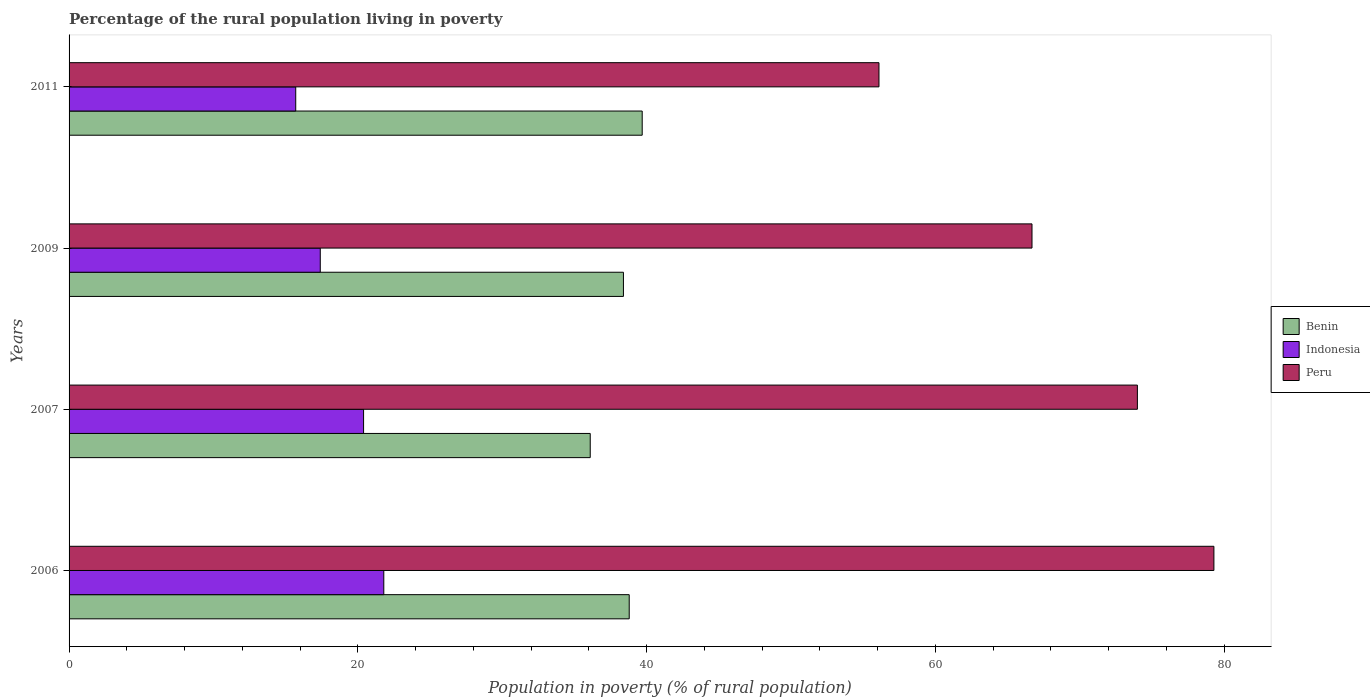How many different coloured bars are there?
Ensure brevity in your answer.  3. How many groups of bars are there?
Offer a terse response. 4. Are the number of bars per tick equal to the number of legend labels?
Your response must be concise. Yes. Are the number of bars on each tick of the Y-axis equal?
Ensure brevity in your answer.  Yes. How many bars are there on the 4th tick from the top?
Your answer should be very brief. 3. What is the label of the 4th group of bars from the top?
Your answer should be very brief. 2006. In how many cases, is the number of bars for a given year not equal to the number of legend labels?
Provide a succinct answer. 0. What is the percentage of the rural population living in poverty in Indonesia in 2007?
Ensure brevity in your answer.  20.4. Across all years, what is the maximum percentage of the rural population living in poverty in Peru?
Give a very brief answer. 79.3. Across all years, what is the minimum percentage of the rural population living in poverty in Indonesia?
Provide a succinct answer. 15.7. In which year was the percentage of the rural population living in poverty in Indonesia minimum?
Your answer should be very brief. 2011. What is the total percentage of the rural population living in poverty in Indonesia in the graph?
Offer a very short reply. 75.3. What is the difference between the percentage of the rural population living in poverty in Peru in 2006 and that in 2007?
Offer a terse response. 5.3. What is the difference between the percentage of the rural population living in poverty in Peru in 2011 and the percentage of the rural population living in poverty in Indonesia in 2007?
Provide a short and direct response. 35.7. What is the average percentage of the rural population living in poverty in Indonesia per year?
Keep it short and to the point. 18.82. In the year 2011, what is the difference between the percentage of the rural population living in poverty in Peru and percentage of the rural population living in poverty in Indonesia?
Keep it short and to the point. 40.4. What is the ratio of the percentage of the rural population living in poverty in Indonesia in 2006 to that in 2007?
Ensure brevity in your answer.  1.07. Is the percentage of the rural population living in poverty in Indonesia in 2009 less than that in 2011?
Your answer should be compact. No. Is the difference between the percentage of the rural population living in poverty in Peru in 2007 and 2009 greater than the difference between the percentage of the rural population living in poverty in Indonesia in 2007 and 2009?
Offer a terse response. Yes. What is the difference between the highest and the second highest percentage of the rural population living in poverty in Benin?
Offer a very short reply. 0.9. What is the difference between the highest and the lowest percentage of the rural population living in poverty in Peru?
Keep it short and to the point. 23.2. Is the sum of the percentage of the rural population living in poverty in Peru in 2007 and 2009 greater than the maximum percentage of the rural population living in poverty in Benin across all years?
Your answer should be compact. Yes. What does the 3rd bar from the top in 2006 represents?
Provide a short and direct response. Benin. Is it the case that in every year, the sum of the percentage of the rural population living in poverty in Peru and percentage of the rural population living in poverty in Indonesia is greater than the percentage of the rural population living in poverty in Benin?
Provide a succinct answer. Yes. How many bars are there?
Give a very brief answer. 12. How many years are there in the graph?
Offer a very short reply. 4. Are the values on the major ticks of X-axis written in scientific E-notation?
Offer a very short reply. No. Does the graph contain any zero values?
Provide a short and direct response. No. What is the title of the graph?
Offer a very short reply. Percentage of the rural population living in poverty. What is the label or title of the X-axis?
Keep it short and to the point. Population in poverty (% of rural population). What is the Population in poverty (% of rural population) in Benin in 2006?
Provide a succinct answer. 38.8. What is the Population in poverty (% of rural population) in Indonesia in 2006?
Offer a terse response. 21.8. What is the Population in poverty (% of rural population) of Peru in 2006?
Offer a very short reply. 79.3. What is the Population in poverty (% of rural population) of Benin in 2007?
Your response must be concise. 36.1. What is the Population in poverty (% of rural population) of Indonesia in 2007?
Give a very brief answer. 20.4. What is the Population in poverty (% of rural population) in Benin in 2009?
Your response must be concise. 38.4. What is the Population in poverty (% of rural population) in Indonesia in 2009?
Provide a succinct answer. 17.4. What is the Population in poverty (% of rural population) of Peru in 2009?
Your response must be concise. 66.7. What is the Population in poverty (% of rural population) of Benin in 2011?
Make the answer very short. 39.7. What is the Population in poverty (% of rural population) in Peru in 2011?
Provide a succinct answer. 56.1. Across all years, what is the maximum Population in poverty (% of rural population) of Benin?
Your answer should be very brief. 39.7. Across all years, what is the maximum Population in poverty (% of rural population) of Indonesia?
Provide a short and direct response. 21.8. Across all years, what is the maximum Population in poverty (% of rural population) of Peru?
Offer a very short reply. 79.3. Across all years, what is the minimum Population in poverty (% of rural population) in Benin?
Provide a short and direct response. 36.1. Across all years, what is the minimum Population in poverty (% of rural population) of Peru?
Provide a short and direct response. 56.1. What is the total Population in poverty (% of rural population) in Benin in the graph?
Offer a terse response. 153. What is the total Population in poverty (% of rural population) of Indonesia in the graph?
Offer a very short reply. 75.3. What is the total Population in poverty (% of rural population) of Peru in the graph?
Keep it short and to the point. 276.1. What is the difference between the Population in poverty (% of rural population) in Indonesia in 2006 and that in 2007?
Keep it short and to the point. 1.4. What is the difference between the Population in poverty (% of rural population) in Benin in 2006 and that in 2009?
Keep it short and to the point. 0.4. What is the difference between the Population in poverty (% of rural population) of Indonesia in 2006 and that in 2009?
Provide a succinct answer. 4.4. What is the difference between the Population in poverty (% of rural population) in Peru in 2006 and that in 2009?
Ensure brevity in your answer.  12.6. What is the difference between the Population in poverty (% of rural population) in Indonesia in 2006 and that in 2011?
Give a very brief answer. 6.1. What is the difference between the Population in poverty (% of rural population) of Peru in 2006 and that in 2011?
Your response must be concise. 23.2. What is the difference between the Population in poverty (% of rural population) in Benin in 2007 and that in 2011?
Your answer should be compact. -3.6. What is the difference between the Population in poverty (% of rural population) of Indonesia in 2007 and that in 2011?
Your answer should be very brief. 4.7. What is the difference between the Population in poverty (% of rural population) of Benin in 2006 and the Population in poverty (% of rural population) of Indonesia in 2007?
Provide a succinct answer. 18.4. What is the difference between the Population in poverty (% of rural population) in Benin in 2006 and the Population in poverty (% of rural population) in Peru in 2007?
Offer a very short reply. -35.2. What is the difference between the Population in poverty (% of rural population) in Indonesia in 2006 and the Population in poverty (% of rural population) in Peru in 2007?
Ensure brevity in your answer.  -52.2. What is the difference between the Population in poverty (% of rural population) of Benin in 2006 and the Population in poverty (% of rural population) of Indonesia in 2009?
Give a very brief answer. 21.4. What is the difference between the Population in poverty (% of rural population) in Benin in 2006 and the Population in poverty (% of rural population) in Peru in 2009?
Your response must be concise. -27.9. What is the difference between the Population in poverty (% of rural population) of Indonesia in 2006 and the Population in poverty (% of rural population) of Peru in 2009?
Ensure brevity in your answer.  -44.9. What is the difference between the Population in poverty (% of rural population) of Benin in 2006 and the Population in poverty (% of rural population) of Indonesia in 2011?
Your response must be concise. 23.1. What is the difference between the Population in poverty (% of rural population) in Benin in 2006 and the Population in poverty (% of rural population) in Peru in 2011?
Your answer should be compact. -17.3. What is the difference between the Population in poverty (% of rural population) of Indonesia in 2006 and the Population in poverty (% of rural population) of Peru in 2011?
Your answer should be compact. -34.3. What is the difference between the Population in poverty (% of rural population) of Benin in 2007 and the Population in poverty (% of rural population) of Indonesia in 2009?
Provide a short and direct response. 18.7. What is the difference between the Population in poverty (% of rural population) in Benin in 2007 and the Population in poverty (% of rural population) in Peru in 2009?
Keep it short and to the point. -30.6. What is the difference between the Population in poverty (% of rural population) of Indonesia in 2007 and the Population in poverty (% of rural population) of Peru in 2009?
Provide a short and direct response. -46.3. What is the difference between the Population in poverty (% of rural population) of Benin in 2007 and the Population in poverty (% of rural population) of Indonesia in 2011?
Your answer should be compact. 20.4. What is the difference between the Population in poverty (% of rural population) in Indonesia in 2007 and the Population in poverty (% of rural population) in Peru in 2011?
Your response must be concise. -35.7. What is the difference between the Population in poverty (% of rural population) of Benin in 2009 and the Population in poverty (% of rural population) of Indonesia in 2011?
Your answer should be compact. 22.7. What is the difference between the Population in poverty (% of rural population) of Benin in 2009 and the Population in poverty (% of rural population) of Peru in 2011?
Make the answer very short. -17.7. What is the difference between the Population in poverty (% of rural population) in Indonesia in 2009 and the Population in poverty (% of rural population) in Peru in 2011?
Provide a succinct answer. -38.7. What is the average Population in poverty (% of rural population) in Benin per year?
Your response must be concise. 38.25. What is the average Population in poverty (% of rural population) in Indonesia per year?
Give a very brief answer. 18.82. What is the average Population in poverty (% of rural population) of Peru per year?
Offer a terse response. 69.03. In the year 2006, what is the difference between the Population in poverty (% of rural population) of Benin and Population in poverty (% of rural population) of Indonesia?
Provide a succinct answer. 17. In the year 2006, what is the difference between the Population in poverty (% of rural population) in Benin and Population in poverty (% of rural population) in Peru?
Offer a terse response. -40.5. In the year 2006, what is the difference between the Population in poverty (% of rural population) in Indonesia and Population in poverty (% of rural population) in Peru?
Your answer should be very brief. -57.5. In the year 2007, what is the difference between the Population in poverty (% of rural population) in Benin and Population in poverty (% of rural population) in Indonesia?
Provide a succinct answer. 15.7. In the year 2007, what is the difference between the Population in poverty (% of rural population) in Benin and Population in poverty (% of rural population) in Peru?
Ensure brevity in your answer.  -37.9. In the year 2007, what is the difference between the Population in poverty (% of rural population) in Indonesia and Population in poverty (% of rural population) in Peru?
Provide a succinct answer. -53.6. In the year 2009, what is the difference between the Population in poverty (% of rural population) in Benin and Population in poverty (% of rural population) in Indonesia?
Your response must be concise. 21. In the year 2009, what is the difference between the Population in poverty (% of rural population) in Benin and Population in poverty (% of rural population) in Peru?
Provide a short and direct response. -28.3. In the year 2009, what is the difference between the Population in poverty (% of rural population) in Indonesia and Population in poverty (% of rural population) in Peru?
Make the answer very short. -49.3. In the year 2011, what is the difference between the Population in poverty (% of rural population) in Benin and Population in poverty (% of rural population) in Peru?
Keep it short and to the point. -16.4. In the year 2011, what is the difference between the Population in poverty (% of rural population) of Indonesia and Population in poverty (% of rural population) of Peru?
Your response must be concise. -40.4. What is the ratio of the Population in poverty (% of rural population) in Benin in 2006 to that in 2007?
Provide a succinct answer. 1.07. What is the ratio of the Population in poverty (% of rural population) of Indonesia in 2006 to that in 2007?
Keep it short and to the point. 1.07. What is the ratio of the Population in poverty (% of rural population) in Peru in 2006 to that in 2007?
Offer a very short reply. 1.07. What is the ratio of the Population in poverty (% of rural population) of Benin in 2006 to that in 2009?
Ensure brevity in your answer.  1.01. What is the ratio of the Population in poverty (% of rural population) in Indonesia in 2006 to that in 2009?
Your answer should be very brief. 1.25. What is the ratio of the Population in poverty (% of rural population) of Peru in 2006 to that in 2009?
Your answer should be compact. 1.19. What is the ratio of the Population in poverty (% of rural population) in Benin in 2006 to that in 2011?
Offer a very short reply. 0.98. What is the ratio of the Population in poverty (% of rural population) in Indonesia in 2006 to that in 2011?
Give a very brief answer. 1.39. What is the ratio of the Population in poverty (% of rural population) in Peru in 2006 to that in 2011?
Offer a terse response. 1.41. What is the ratio of the Population in poverty (% of rural population) of Benin in 2007 to that in 2009?
Your response must be concise. 0.94. What is the ratio of the Population in poverty (% of rural population) of Indonesia in 2007 to that in 2009?
Keep it short and to the point. 1.17. What is the ratio of the Population in poverty (% of rural population) of Peru in 2007 to that in 2009?
Your answer should be compact. 1.11. What is the ratio of the Population in poverty (% of rural population) of Benin in 2007 to that in 2011?
Keep it short and to the point. 0.91. What is the ratio of the Population in poverty (% of rural population) in Indonesia in 2007 to that in 2011?
Offer a very short reply. 1.3. What is the ratio of the Population in poverty (% of rural population) in Peru in 2007 to that in 2011?
Provide a succinct answer. 1.32. What is the ratio of the Population in poverty (% of rural population) in Benin in 2009 to that in 2011?
Provide a succinct answer. 0.97. What is the ratio of the Population in poverty (% of rural population) of Indonesia in 2009 to that in 2011?
Provide a succinct answer. 1.11. What is the ratio of the Population in poverty (% of rural population) of Peru in 2009 to that in 2011?
Your answer should be very brief. 1.19. What is the difference between the highest and the second highest Population in poverty (% of rural population) of Benin?
Offer a very short reply. 0.9. What is the difference between the highest and the second highest Population in poverty (% of rural population) of Indonesia?
Make the answer very short. 1.4. What is the difference between the highest and the second highest Population in poverty (% of rural population) in Peru?
Ensure brevity in your answer.  5.3. What is the difference between the highest and the lowest Population in poverty (% of rural population) of Peru?
Offer a very short reply. 23.2. 